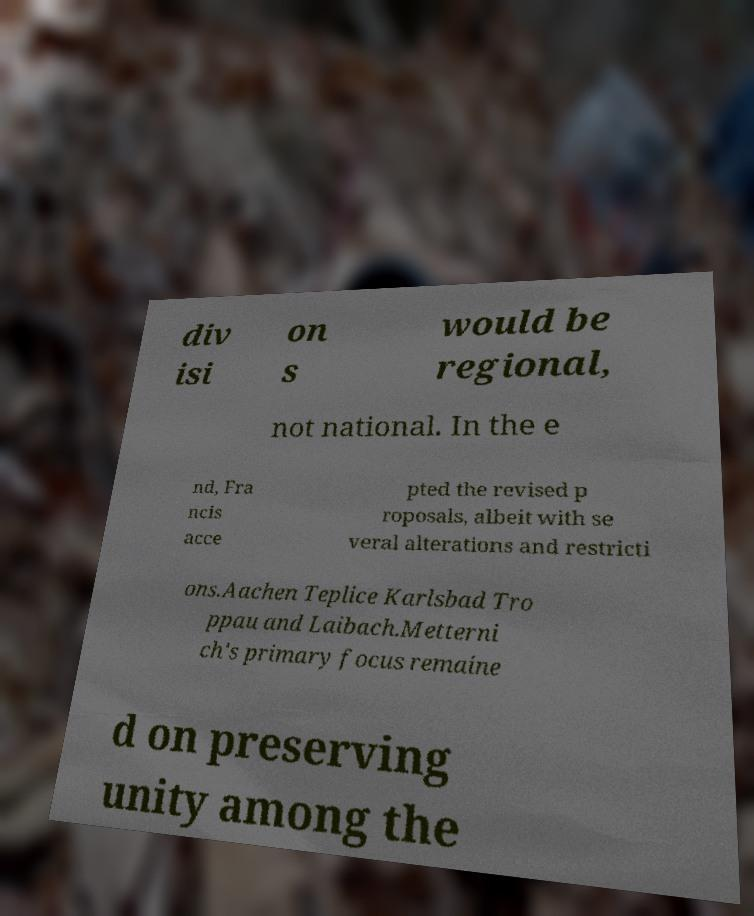For documentation purposes, I need the text within this image transcribed. Could you provide that? div isi on s would be regional, not national. In the e nd, Fra ncis acce pted the revised p roposals, albeit with se veral alterations and restricti ons.Aachen Teplice Karlsbad Tro ppau and Laibach.Metterni ch's primary focus remaine d on preserving unity among the 